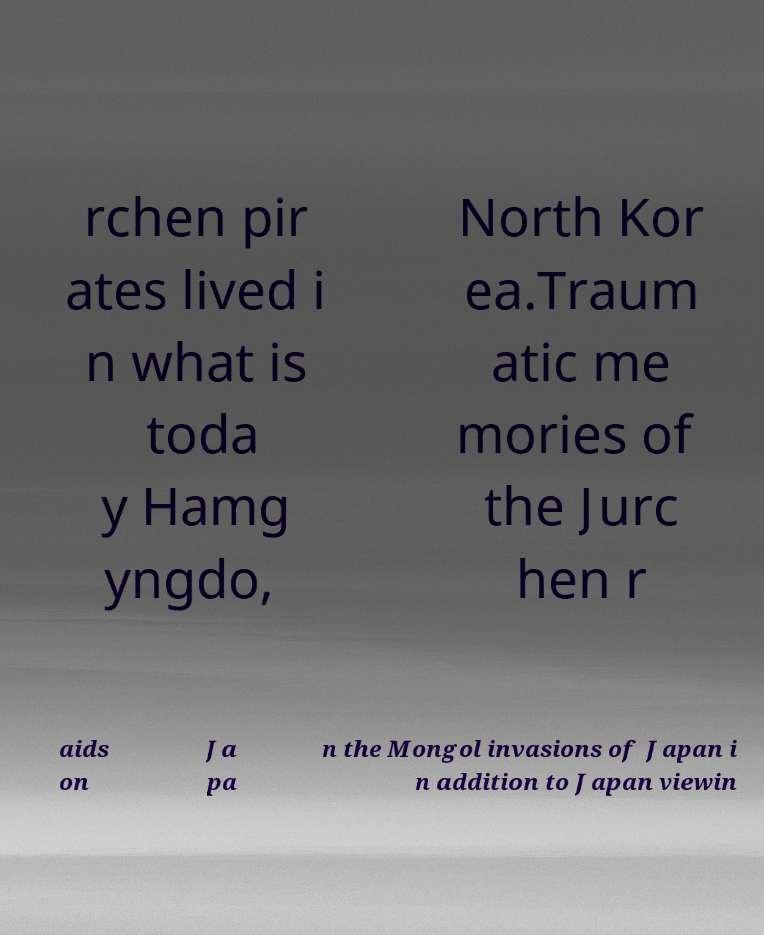Can you accurately transcribe the text from the provided image for me? rchen pir ates lived i n what is toda y Hamg yngdo, North Kor ea.Traum atic me mories of the Jurc hen r aids on Ja pa n the Mongol invasions of Japan i n addition to Japan viewin 